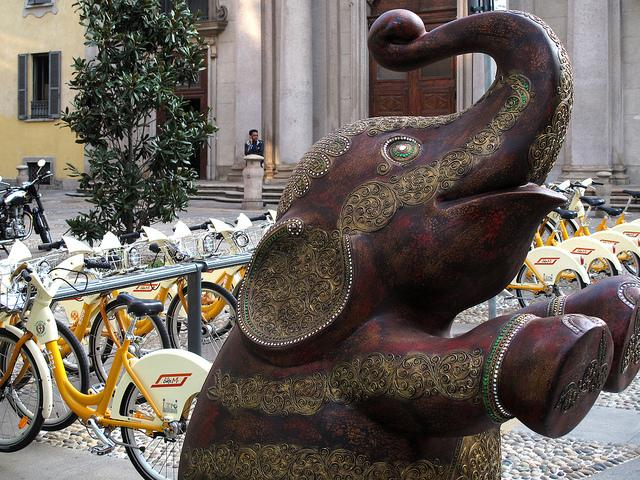Why are all the bikes the same? Please explain your reasoning. rentals. The bikes are lined up in a row to be rented by tourists and are arranged neatly. 